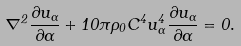<formula> <loc_0><loc_0><loc_500><loc_500>\nabla ^ { 2 } \frac { \partial u _ { \alpha } } { \partial \alpha } + 1 0 \pi \rho _ { 0 } C ^ { 4 } u _ { \alpha } ^ { 4 } \frac { \partial u _ { \alpha } } { \partial \alpha } = 0 .</formula> 